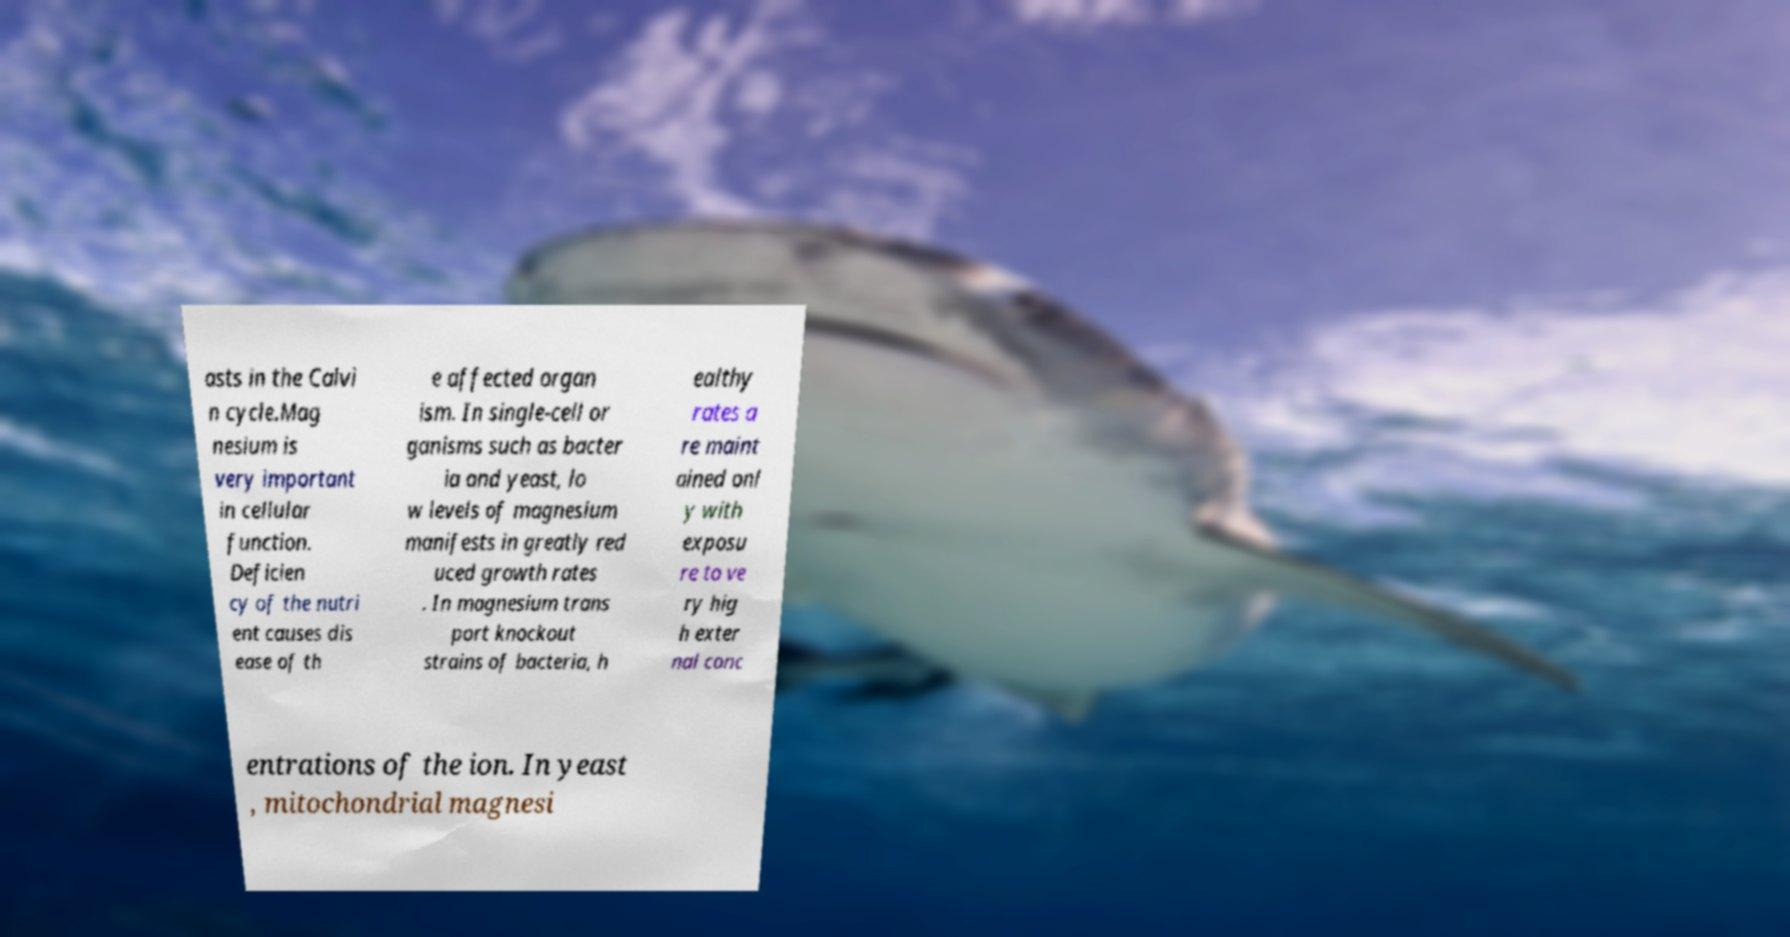What messages or text are displayed in this image? I need them in a readable, typed format. asts in the Calvi n cycle.Mag nesium is very important in cellular function. Deficien cy of the nutri ent causes dis ease of th e affected organ ism. In single-cell or ganisms such as bacter ia and yeast, lo w levels of magnesium manifests in greatly red uced growth rates . In magnesium trans port knockout strains of bacteria, h ealthy rates a re maint ained onl y with exposu re to ve ry hig h exter nal conc entrations of the ion. In yeast , mitochondrial magnesi 